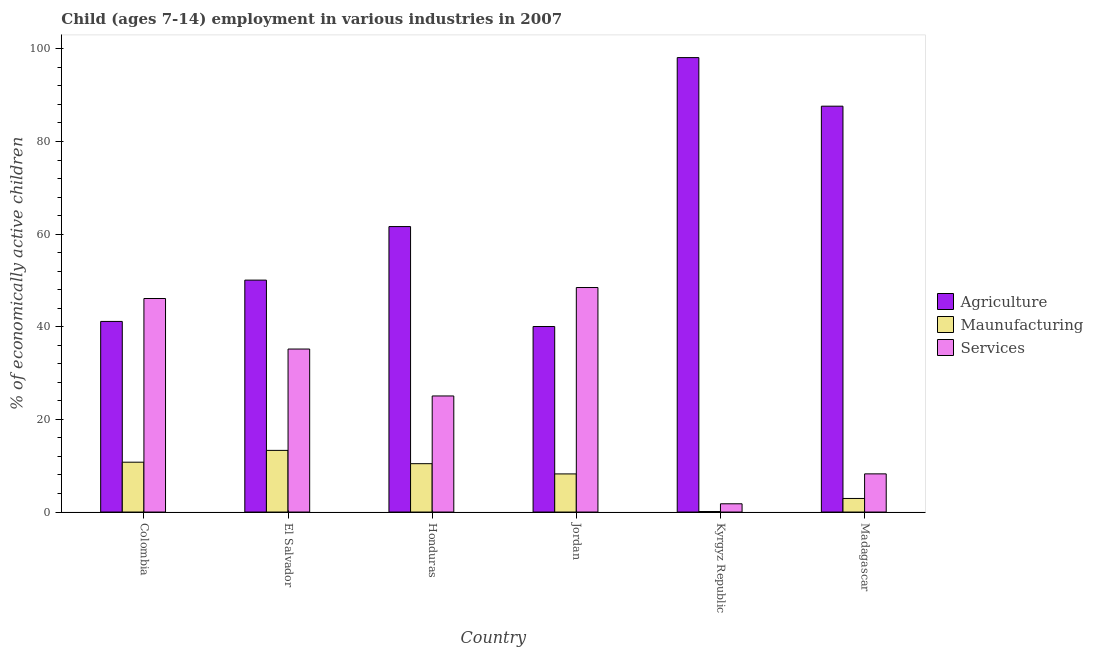How many different coloured bars are there?
Give a very brief answer. 3. How many groups of bars are there?
Ensure brevity in your answer.  6. How many bars are there on the 5th tick from the left?
Make the answer very short. 3. In how many cases, is the number of bars for a given country not equal to the number of legend labels?
Your response must be concise. 0. What is the percentage of economically active children in agriculture in Kyrgyz Republic?
Keep it short and to the point. 98.11. Across all countries, what is the maximum percentage of economically active children in services?
Ensure brevity in your answer.  48.47. Across all countries, what is the minimum percentage of economically active children in agriculture?
Your response must be concise. 40.05. In which country was the percentage of economically active children in services maximum?
Keep it short and to the point. Jordan. In which country was the percentage of economically active children in services minimum?
Give a very brief answer. Kyrgyz Republic. What is the total percentage of economically active children in manufacturing in the graph?
Your response must be concise. 45.78. What is the difference between the percentage of economically active children in agriculture in Colombia and that in El Salvador?
Provide a short and direct response. -8.92. What is the difference between the percentage of economically active children in services in Colombia and the percentage of economically active children in agriculture in El Salvador?
Your answer should be very brief. -3.97. What is the average percentage of economically active children in services per country?
Give a very brief answer. 27.47. What is the difference between the percentage of economically active children in services and percentage of economically active children in manufacturing in Kyrgyz Republic?
Offer a terse response. 1.67. In how many countries, is the percentage of economically active children in services greater than 40 %?
Provide a succinct answer. 2. What is the ratio of the percentage of economically active children in manufacturing in Honduras to that in Madagascar?
Your response must be concise. 3.56. Is the percentage of economically active children in services in Colombia less than that in Madagascar?
Give a very brief answer. No. Is the difference between the percentage of economically active children in services in Colombia and Honduras greater than the difference between the percentage of economically active children in agriculture in Colombia and Honduras?
Keep it short and to the point. Yes. What is the difference between the highest and the second highest percentage of economically active children in services?
Your answer should be very brief. 2.37. What is the difference between the highest and the lowest percentage of economically active children in manufacturing?
Keep it short and to the point. 13.2. Is the sum of the percentage of economically active children in services in Honduras and Kyrgyz Republic greater than the maximum percentage of economically active children in manufacturing across all countries?
Make the answer very short. Yes. What does the 1st bar from the left in Kyrgyz Republic represents?
Your answer should be compact. Agriculture. What does the 3rd bar from the right in Honduras represents?
Give a very brief answer. Agriculture. Is it the case that in every country, the sum of the percentage of economically active children in agriculture and percentage of economically active children in manufacturing is greater than the percentage of economically active children in services?
Provide a short and direct response. No. How many bars are there?
Offer a very short reply. 18. How many countries are there in the graph?
Make the answer very short. 6. How many legend labels are there?
Your answer should be very brief. 3. How are the legend labels stacked?
Your answer should be very brief. Vertical. What is the title of the graph?
Give a very brief answer. Child (ages 7-14) employment in various industries in 2007. Does "Industry" appear as one of the legend labels in the graph?
Offer a terse response. No. What is the label or title of the X-axis?
Your answer should be compact. Country. What is the label or title of the Y-axis?
Your response must be concise. % of economically active children. What is the % of economically active children in Agriculture in Colombia?
Provide a succinct answer. 41.15. What is the % of economically active children of Maunufacturing in Colombia?
Keep it short and to the point. 10.76. What is the % of economically active children in Services in Colombia?
Give a very brief answer. 46.1. What is the % of economically active children of Agriculture in El Salvador?
Make the answer very short. 50.07. What is the % of economically active children in Maunufacturing in El Salvador?
Your response must be concise. 13.31. What is the % of economically active children in Services in El Salvador?
Your response must be concise. 35.19. What is the % of economically active children of Agriculture in Honduras?
Offer a very short reply. 61.63. What is the % of economically active children in Maunufacturing in Honduras?
Your answer should be compact. 10.44. What is the % of economically active children of Services in Honduras?
Provide a succinct answer. 25.06. What is the % of economically active children in Agriculture in Jordan?
Your response must be concise. 40.05. What is the % of economically active children in Maunufacturing in Jordan?
Ensure brevity in your answer.  8.23. What is the % of economically active children of Services in Jordan?
Offer a very short reply. 48.47. What is the % of economically active children of Agriculture in Kyrgyz Republic?
Make the answer very short. 98.11. What is the % of economically active children in Maunufacturing in Kyrgyz Republic?
Your response must be concise. 0.11. What is the % of economically active children in Services in Kyrgyz Republic?
Offer a very short reply. 1.78. What is the % of economically active children in Agriculture in Madagascar?
Provide a succinct answer. 87.62. What is the % of economically active children of Maunufacturing in Madagascar?
Your answer should be compact. 2.93. What is the % of economically active children in Services in Madagascar?
Your answer should be compact. 8.24. Across all countries, what is the maximum % of economically active children of Agriculture?
Provide a short and direct response. 98.11. Across all countries, what is the maximum % of economically active children in Maunufacturing?
Your response must be concise. 13.31. Across all countries, what is the maximum % of economically active children of Services?
Provide a succinct answer. 48.47. Across all countries, what is the minimum % of economically active children in Agriculture?
Offer a very short reply. 40.05. Across all countries, what is the minimum % of economically active children of Maunufacturing?
Give a very brief answer. 0.11. Across all countries, what is the minimum % of economically active children of Services?
Offer a very short reply. 1.78. What is the total % of economically active children in Agriculture in the graph?
Offer a very short reply. 378.63. What is the total % of economically active children in Maunufacturing in the graph?
Keep it short and to the point. 45.78. What is the total % of economically active children in Services in the graph?
Your answer should be compact. 164.84. What is the difference between the % of economically active children of Agriculture in Colombia and that in El Salvador?
Your answer should be compact. -8.92. What is the difference between the % of economically active children in Maunufacturing in Colombia and that in El Salvador?
Give a very brief answer. -2.55. What is the difference between the % of economically active children in Services in Colombia and that in El Salvador?
Your answer should be very brief. 10.91. What is the difference between the % of economically active children of Agriculture in Colombia and that in Honduras?
Ensure brevity in your answer.  -20.48. What is the difference between the % of economically active children in Maunufacturing in Colombia and that in Honduras?
Offer a very short reply. 0.32. What is the difference between the % of economically active children of Services in Colombia and that in Honduras?
Provide a short and direct response. 21.04. What is the difference between the % of economically active children of Agriculture in Colombia and that in Jordan?
Make the answer very short. 1.1. What is the difference between the % of economically active children of Maunufacturing in Colombia and that in Jordan?
Provide a short and direct response. 2.53. What is the difference between the % of economically active children in Services in Colombia and that in Jordan?
Make the answer very short. -2.37. What is the difference between the % of economically active children of Agriculture in Colombia and that in Kyrgyz Republic?
Your answer should be compact. -56.96. What is the difference between the % of economically active children in Maunufacturing in Colombia and that in Kyrgyz Republic?
Offer a terse response. 10.65. What is the difference between the % of economically active children of Services in Colombia and that in Kyrgyz Republic?
Make the answer very short. 44.32. What is the difference between the % of economically active children of Agriculture in Colombia and that in Madagascar?
Your answer should be very brief. -46.47. What is the difference between the % of economically active children in Maunufacturing in Colombia and that in Madagascar?
Offer a terse response. 7.83. What is the difference between the % of economically active children of Services in Colombia and that in Madagascar?
Your answer should be compact. 37.86. What is the difference between the % of economically active children of Agriculture in El Salvador and that in Honduras?
Provide a succinct answer. -11.56. What is the difference between the % of economically active children in Maunufacturing in El Salvador and that in Honduras?
Provide a short and direct response. 2.87. What is the difference between the % of economically active children of Services in El Salvador and that in Honduras?
Offer a terse response. 10.13. What is the difference between the % of economically active children in Agriculture in El Salvador and that in Jordan?
Ensure brevity in your answer.  10.02. What is the difference between the % of economically active children in Maunufacturing in El Salvador and that in Jordan?
Ensure brevity in your answer.  5.08. What is the difference between the % of economically active children in Services in El Salvador and that in Jordan?
Keep it short and to the point. -13.28. What is the difference between the % of economically active children of Agriculture in El Salvador and that in Kyrgyz Republic?
Make the answer very short. -48.04. What is the difference between the % of economically active children in Maunufacturing in El Salvador and that in Kyrgyz Republic?
Keep it short and to the point. 13.2. What is the difference between the % of economically active children in Services in El Salvador and that in Kyrgyz Republic?
Offer a very short reply. 33.41. What is the difference between the % of economically active children of Agriculture in El Salvador and that in Madagascar?
Your answer should be compact. -37.55. What is the difference between the % of economically active children of Maunufacturing in El Salvador and that in Madagascar?
Offer a very short reply. 10.38. What is the difference between the % of economically active children in Services in El Salvador and that in Madagascar?
Offer a terse response. 26.95. What is the difference between the % of economically active children in Agriculture in Honduras and that in Jordan?
Your answer should be compact. 21.58. What is the difference between the % of economically active children in Maunufacturing in Honduras and that in Jordan?
Give a very brief answer. 2.21. What is the difference between the % of economically active children in Services in Honduras and that in Jordan?
Offer a very short reply. -23.41. What is the difference between the % of economically active children in Agriculture in Honduras and that in Kyrgyz Republic?
Provide a succinct answer. -36.48. What is the difference between the % of economically active children of Maunufacturing in Honduras and that in Kyrgyz Republic?
Your response must be concise. 10.33. What is the difference between the % of economically active children of Services in Honduras and that in Kyrgyz Republic?
Ensure brevity in your answer.  23.28. What is the difference between the % of economically active children in Agriculture in Honduras and that in Madagascar?
Ensure brevity in your answer.  -25.99. What is the difference between the % of economically active children in Maunufacturing in Honduras and that in Madagascar?
Offer a very short reply. 7.51. What is the difference between the % of economically active children in Services in Honduras and that in Madagascar?
Make the answer very short. 16.82. What is the difference between the % of economically active children in Agriculture in Jordan and that in Kyrgyz Republic?
Your answer should be very brief. -58.06. What is the difference between the % of economically active children in Maunufacturing in Jordan and that in Kyrgyz Republic?
Ensure brevity in your answer.  8.12. What is the difference between the % of economically active children of Services in Jordan and that in Kyrgyz Republic?
Offer a terse response. 46.69. What is the difference between the % of economically active children in Agriculture in Jordan and that in Madagascar?
Your response must be concise. -47.57. What is the difference between the % of economically active children in Maunufacturing in Jordan and that in Madagascar?
Make the answer very short. 5.3. What is the difference between the % of economically active children of Services in Jordan and that in Madagascar?
Your answer should be compact. 40.23. What is the difference between the % of economically active children in Agriculture in Kyrgyz Republic and that in Madagascar?
Offer a terse response. 10.49. What is the difference between the % of economically active children of Maunufacturing in Kyrgyz Republic and that in Madagascar?
Provide a succinct answer. -2.82. What is the difference between the % of economically active children in Services in Kyrgyz Republic and that in Madagascar?
Your answer should be compact. -6.46. What is the difference between the % of economically active children in Agriculture in Colombia and the % of economically active children in Maunufacturing in El Salvador?
Provide a succinct answer. 27.84. What is the difference between the % of economically active children in Agriculture in Colombia and the % of economically active children in Services in El Salvador?
Ensure brevity in your answer.  5.96. What is the difference between the % of economically active children of Maunufacturing in Colombia and the % of economically active children of Services in El Salvador?
Offer a terse response. -24.43. What is the difference between the % of economically active children of Agriculture in Colombia and the % of economically active children of Maunufacturing in Honduras?
Offer a terse response. 30.71. What is the difference between the % of economically active children in Agriculture in Colombia and the % of economically active children in Services in Honduras?
Keep it short and to the point. 16.09. What is the difference between the % of economically active children of Maunufacturing in Colombia and the % of economically active children of Services in Honduras?
Keep it short and to the point. -14.3. What is the difference between the % of economically active children of Agriculture in Colombia and the % of economically active children of Maunufacturing in Jordan?
Your response must be concise. 32.92. What is the difference between the % of economically active children of Agriculture in Colombia and the % of economically active children of Services in Jordan?
Offer a terse response. -7.32. What is the difference between the % of economically active children in Maunufacturing in Colombia and the % of economically active children in Services in Jordan?
Offer a terse response. -37.71. What is the difference between the % of economically active children of Agriculture in Colombia and the % of economically active children of Maunufacturing in Kyrgyz Republic?
Offer a terse response. 41.04. What is the difference between the % of economically active children of Agriculture in Colombia and the % of economically active children of Services in Kyrgyz Republic?
Provide a short and direct response. 39.37. What is the difference between the % of economically active children of Maunufacturing in Colombia and the % of economically active children of Services in Kyrgyz Republic?
Your answer should be very brief. 8.98. What is the difference between the % of economically active children in Agriculture in Colombia and the % of economically active children in Maunufacturing in Madagascar?
Provide a succinct answer. 38.22. What is the difference between the % of economically active children of Agriculture in Colombia and the % of economically active children of Services in Madagascar?
Your response must be concise. 32.91. What is the difference between the % of economically active children of Maunufacturing in Colombia and the % of economically active children of Services in Madagascar?
Offer a terse response. 2.52. What is the difference between the % of economically active children of Agriculture in El Salvador and the % of economically active children of Maunufacturing in Honduras?
Offer a terse response. 39.63. What is the difference between the % of economically active children of Agriculture in El Salvador and the % of economically active children of Services in Honduras?
Give a very brief answer. 25.01. What is the difference between the % of economically active children of Maunufacturing in El Salvador and the % of economically active children of Services in Honduras?
Give a very brief answer. -11.75. What is the difference between the % of economically active children of Agriculture in El Salvador and the % of economically active children of Maunufacturing in Jordan?
Your response must be concise. 41.84. What is the difference between the % of economically active children of Maunufacturing in El Salvador and the % of economically active children of Services in Jordan?
Provide a succinct answer. -35.16. What is the difference between the % of economically active children in Agriculture in El Salvador and the % of economically active children in Maunufacturing in Kyrgyz Republic?
Make the answer very short. 49.96. What is the difference between the % of economically active children in Agriculture in El Salvador and the % of economically active children in Services in Kyrgyz Republic?
Your response must be concise. 48.29. What is the difference between the % of economically active children in Maunufacturing in El Salvador and the % of economically active children in Services in Kyrgyz Republic?
Offer a very short reply. 11.53. What is the difference between the % of economically active children of Agriculture in El Salvador and the % of economically active children of Maunufacturing in Madagascar?
Offer a very short reply. 47.14. What is the difference between the % of economically active children in Agriculture in El Salvador and the % of economically active children in Services in Madagascar?
Offer a very short reply. 41.83. What is the difference between the % of economically active children of Maunufacturing in El Salvador and the % of economically active children of Services in Madagascar?
Your answer should be very brief. 5.07. What is the difference between the % of economically active children of Agriculture in Honduras and the % of economically active children of Maunufacturing in Jordan?
Offer a very short reply. 53.4. What is the difference between the % of economically active children in Agriculture in Honduras and the % of economically active children in Services in Jordan?
Ensure brevity in your answer.  13.16. What is the difference between the % of economically active children of Maunufacturing in Honduras and the % of economically active children of Services in Jordan?
Offer a very short reply. -38.03. What is the difference between the % of economically active children of Agriculture in Honduras and the % of economically active children of Maunufacturing in Kyrgyz Republic?
Offer a very short reply. 61.52. What is the difference between the % of economically active children in Agriculture in Honduras and the % of economically active children in Services in Kyrgyz Republic?
Your answer should be very brief. 59.85. What is the difference between the % of economically active children of Maunufacturing in Honduras and the % of economically active children of Services in Kyrgyz Republic?
Offer a terse response. 8.66. What is the difference between the % of economically active children in Agriculture in Honduras and the % of economically active children in Maunufacturing in Madagascar?
Offer a terse response. 58.7. What is the difference between the % of economically active children in Agriculture in Honduras and the % of economically active children in Services in Madagascar?
Provide a succinct answer. 53.39. What is the difference between the % of economically active children of Agriculture in Jordan and the % of economically active children of Maunufacturing in Kyrgyz Republic?
Provide a short and direct response. 39.94. What is the difference between the % of economically active children in Agriculture in Jordan and the % of economically active children in Services in Kyrgyz Republic?
Your answer should be compact. 38.27. What is the difference between the % of economically active children in Maunufacturing in Jordan and the % of economically active children in Services in Kyrgyz Republic?
Ensure brevity in your answer.  6.45. What is the difference between the % of economically active children in Agriculture in Jordan and the % of economically active children in Maunufacturing in Madagascar?
Make the answer very short. 37.12. What is the difference between the % of economically active children in Agriculture in Jordan and the % of economically active children in Services in Madagascar?
Offer a very short reply. 31.81. What is the difference between the % of economically active children in Maunufacturing in Jordan and the % of economically active children in Services in Madagascar?
Your answer should be very brief. -0.01. What is the difference between the % of economically active children in Agriculture in Kyrgyz Republic and the % of economically active children in Maunufacturing in Madagascar?
Provide a short and direct response. 95.18. What is the difference between the % of economically active children in Agriculture in Kyrgyz Republic and the % of economically active children in Services in Madagascar?
Your answer should be compact. 89.87. What is the difference between the % of economically active children in Maunufacturing in Kyrgyz Republic and the % of economically active children in Services in Madagascar?
Offer a terse response. -8.13. What is the average % of economically active children in Agriculture per country?
Offer a terse response. 63.1. What is the average % of economically active children in Maunufacturing per country?
Offer a very short reply. 7.63. What is the average % of economically active children of Services per country?
Your response must be concise. 27.47. What is the difference between the % of economically active children in Agriculture and % of economically active children in Maunufacturing in Colombia?
Make the answer very short. 30.39. What is the difference between the % of economically active children in Agriculture and % of economically active children in Services in Colombia?
Provide a succinct answer. -4.95. What is the difference between the % of economically active children in Maunufacturing and % of economically active children in Services in Colombia?
Make the answer very short. -35.34. What is the difference between the % of economically active children in Agriculture and % of economically active children in Maunufacturing in El Salvador?
Your response must be concise. 36.76. What is the difference between the % of economically active children of Agriculture and % of economically active children of Services in El Salvador?
Your response must be concise. 14.88. What is the difference between the % of economically active children of Maunufacturing and % of economically active children of Services in El Salvador?
Your response must be concise. -21.88. What is the difference between the % of economically active children in Agriculture and % of economically active children in Maunufacturing in Honduras?
Ensure brevity in your answer.  51.19. What is the difference between the % of economically active children of Agriculture and % of economically active children of Services in Honduras?
Give a very brief answer. 36.57. What is the difference between the % of economically active children of Maunufacturing and % of economically active children of Services in Honduras?
Your answer should be very brief. -14.62. What is the difference between the % of economically active children in Agriculture and % of economically active children in Maunufacturing in Jordan?
Make the answer very short. 31.82. What is the difference between the % of economically active children of Agriculture and % of economically active children of Services in Jordan?
Provide a short and direct response. -8.42. What is the difference between the % of economically active children in Maunufacturing and % of economically active children in Services in Jordan?
Offer a terse response. -40.24. What is the difference between the % of economically active children of Agriculture and % of economically active children of Maunufacturing in Kyrgyz Republic?
Your response must be concise. 98. What is the difference between the % of economically active children in Agriculture and % of economically active children in Services in Kyrgyz Republic?
Provide a short and direct response. 96.33. What is the difference between the % of economically active children in Maunufacturing and % of economically active children in Services in Kyrgyz Republic?
Provide a short and direct response. -1.67. What is the difference between the % of economically active children of Agriculture and % of economically active children of Maunufacturing in Madagascar?
Provide a succinct answer. 84.69. What is the difference between the % of economically active children in Agriculture and % of economically active children in Services in Madagascar?
Make the answer very short. 79.38. What is the difference between the % of economically active children of Maunufacturing and % of economically active children of Services in Madagascar?
Your answer should be very brief. -5.31. What is the ratio of the % of economically active children of Agriculture in Colombia to that in El Salvador?
Provide a short and direct response. 0.82. What is the ratio of the % of economically active children of Maunufacturing in Colombia to that in El Salvador?
Ensure brevity in your answer.  0.81. What is the ratio of the % of economically active children in Services in Colombia to that in El Salvador?
Offer a terse response. 1.31. What is the ratio of the % of economically active children of Agriculture in Colombia to that in Honduras?
Offer a very short reply. 0.67. What is the ratio of the % of economically active children of Maunufacturing in Colombia to that in Honduras?
Your answer should be very brief. 1.03. What is the ratio of the % of economically active children of Services in Colombia to that in Honduras?
Give a very brief answer. 1.84. What is the ratio of the % of economically active children of Agriculture in Colombia to that in Jordan?
Give a very brief answer. 1.03. What is the ratio of the % of economically active children in Maunufacturing in Colombia to that in Jordan?
Keep it short and to the point. 1.31. What is the ratio of the % of economically active children in Services in Colombia to that in Jordan?
Your answer should be compact. 0.95. What is the ratio of the % of economically active children of Agriculture in Colombia to that in Kyrgyz Republic?
Your answer should be compact. 0.42. What is the ratio of the % of economically active children of Maunufacturing in Colombia to that in Kyrgyz Republic?
Offer a terse response. 97.82. What is the ratio of the % of economically active children in Services in Colombia to that in Kyrgyz Republic?
Provide a succinct answer. 25.9. What is the ratio of the % of economically active children in Agriculture in Colombia to that in Madagascar?
Your answer should be very brief. 0.47. What is the ratio of the % of economically active children in Maunufacturing in Colombia to that in Madagascar?
Provide a succinct answer. 3.67. What is the ratio of the % of economically active children in Services in Colombia to that in Madagascar?
Offer a terse response. 5.59. What is the ratio of the % of economically active children in Agriculture in El Salvador to that in Honduras?
Offer a terse response. 0.81. What is the ratio of the % of economically active children of Maunufacturing in El Salvador to that in Honduras?
Ensure brevity in your answer.  1.27. What is the ratio of the % of economically active children of Services in El Salvador to that in Honduras?
Offer a very short reply. 1.4. What is the ratio of the % of economically active children in Agriculture in El Salvador to that in Jordan?
Provide a short and direct response. 1.25. What is the ratio of the % of economically active children of Maunufacturing in El Salvador to that in Jordan?
Make the answer very short. 1.62. What is the ratio of the % of economically active children in Services in El Salvador to that in Jordan?
Provide a succinct answer. 0.73. What is the ratio of the % of economically active children of Agriculture in El Salvador to that in Kyrgyz Republic?
Provide a short and direct response. 0.51. What is the ratio of the % of economically active children in Maunufacturing in El Salvador to that in Kyrgyz Republic?
Your answer should be very brief. 121. What is the ratio of the % of economically active children in Services in El Salvador to that in Kyrgyz Republic?
Provide a succinct answer. 19.77. What is the ratio of the % of economically active children of Maunufacturing in El Salvador to that in Madagascar?
Give a very brief answer. 4.54. What is the ratio of the % of economically active children in Services in El Salvador to that in Madagascar?
Make the answer very short. 4.27. What is the ratio of the % of economically active children of Agriculture in Honduras to that in Jordan?
Offer a very short reply. 1.54. What is the ratio of the % of economically active children of Maunufacturing in Honduras to that in Jordan?
Give a very brief answer. 1.27. What is the ratio of the % of economically active children of Services in Honduras to that in Jordan?
Provide a succinct answer. 0.52. What is the ratio of the % of economically active children of Agriculture in Honduras to that in Kyrgyz Republic?
Your answer should be very brief. 0.63. What is the ratio of the % of economically active children of Maunufacturing in Honduras to that in Kyrgyz Republic?
Your response must be concise. 94.91. What is the ratio of the % of economically active children in Services in Honduras to that in Kyrgyz Republic?
Give a very brief answer. 14.08. What is the ratio of the % of economically active children in Agriculture in Honduras to that in Madagascar?
Your response must be concise. 0.7. What is the ratio of the % of economically active children of Maunufacturing in Honduras to that in Madagascar?
Give a very brief answer. 3.56. What is the ratio of the % of economically active children of Services in Honduras to that in Madagascar?
Provide a succinct answer. 3.04. What is the ratio of the % of economically active children of Agriculture in Jordan to that in Kyrgyz Republic?
Give a very brief answer. 0.41. What is the ratio of the % of economically active children in Maunufacturing in Jordan to that in Kyrgyz Republic?
Offer a very short reply. 74.82. What is the ratio of the % of economically active children of Services in Jordan to that in Kyrgyz Republic?
Ensure brevity in your answer.  27.23. What is the ratio of the % of economically active children of Agriculture in Jordan to that in Madagascar?
Your answer should be compact. 0.46. What is the ratio of the % of economically active children in Maunufacturing in Jordan to that in Madagascar?
Make the answer very short. 2.81. What is the ratio of the % of economically active children in Services in Jordan to that in Madagascar?
Provide a short and direct response. 5.88. What is the ratio of the % of economically active children in Agriculture in Kyrgyz Republic to that in Madagascar?
Give a very brief answer. 1.12. What is the ratio of the % of economically active children of Maunufacturing in Kyrgyz Republic to that in Madagascar?
Ensure brevity in your answer.  0.04. What is the ratio of the % of economically active children of Services in Kyrgyz Republic to that in Madagascar?
Offer a terse response. 0.22. What is the difference between the highest and the second highest % of economically active children of Agriculture?
Ensure brevity in your answer.  10.49. What is the difference between the highest and the second highest % of economically active children of Maunufacturing?
Your answer should be compact. 2.55. What is the difference between the highest and the second highest % of economically active children of Services?
Provide a succinct answer. 2.37. What is the difference between the highest and the lowest % of economically active children of Agriculture?
Your answer should be very brief. 58.06. What is the difference between the highest and the lowest % of economically active children in Services?
Keep it short and to the point. 46.69. 